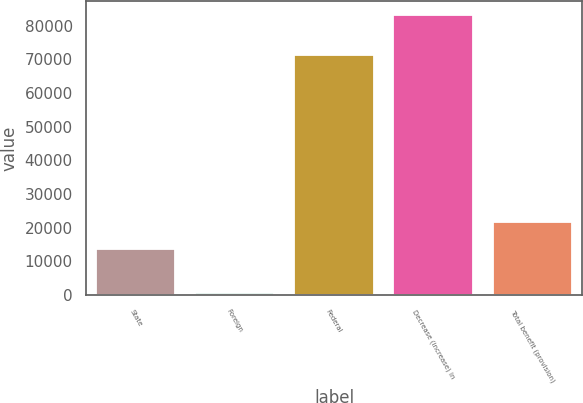Convert chart to OTSL. <chart><loc_0><loc_0><loc_500><loc_500><bar_chart><fcel>State<fcel>Foreign<fcel>Federal<fcel>Decrease (increase) in<fcel>Total benefit (provision)<nl><fcel>13608<fcel>739<fcel>71318<fcel>83009<fcel>21835<nl></chart> 